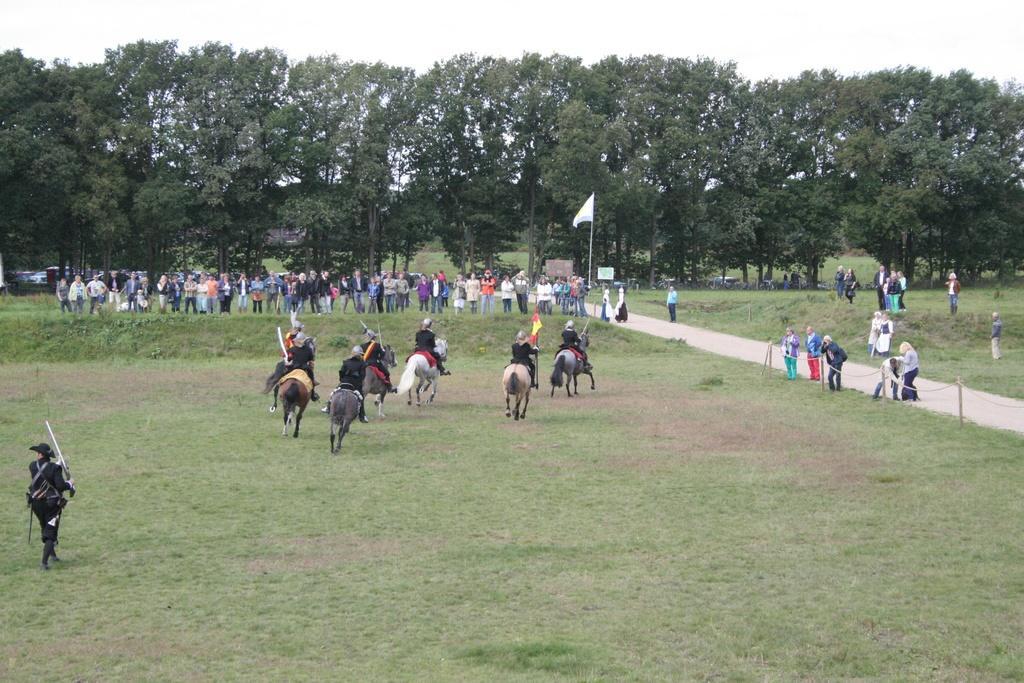Please provide a concise description of this image. Few people are sitting on horses. Land is covered with grass. Background we can see flag, boards, people, trees and sky. One person is holding a flag. 